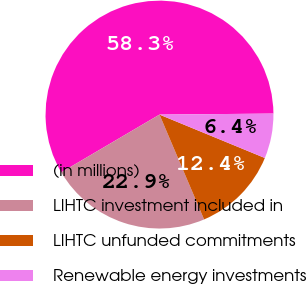Convert chart. <chart><loc_0><loc_0><loc_500><loc_500><pie_chart><fcel>(in millions)<fcel>LIHTC investment included in<fcel>LIHTC unfunded commitments<fcel>Renewable energy investments<nl><fcel>58.32%<fcel>22.94%<fcel>12.38%<fcel>6.36%<nl></chart> 